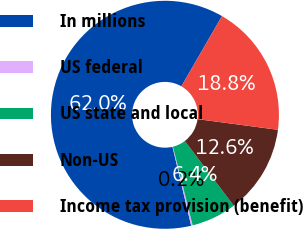Convert chart. <chart><loc_0><loc_0><loc_500><loc_500><pie_chart><fcel>In millions<fcel>US federal<fcel>US state and local<fcel>Non-US<fcel>Income tax provision (benefit)<nl><fcel>62.04%<fcel>0.22%<fcel>6.4%<fcel>12.58%<fcel>18.76%<nl></chart> 